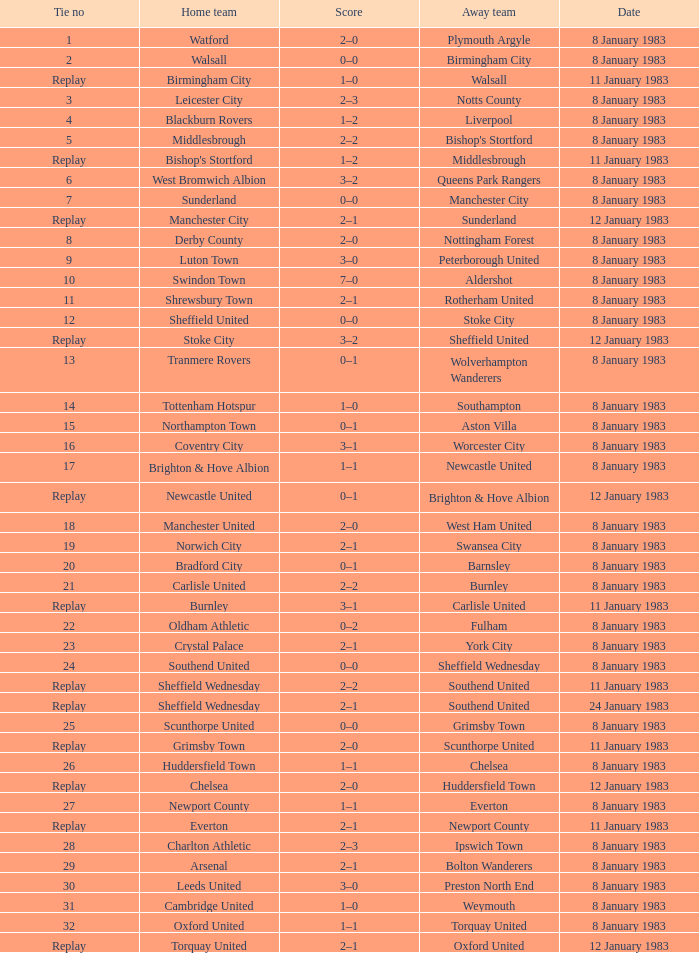On what date was Tie #13 played? 8 January 1983. 